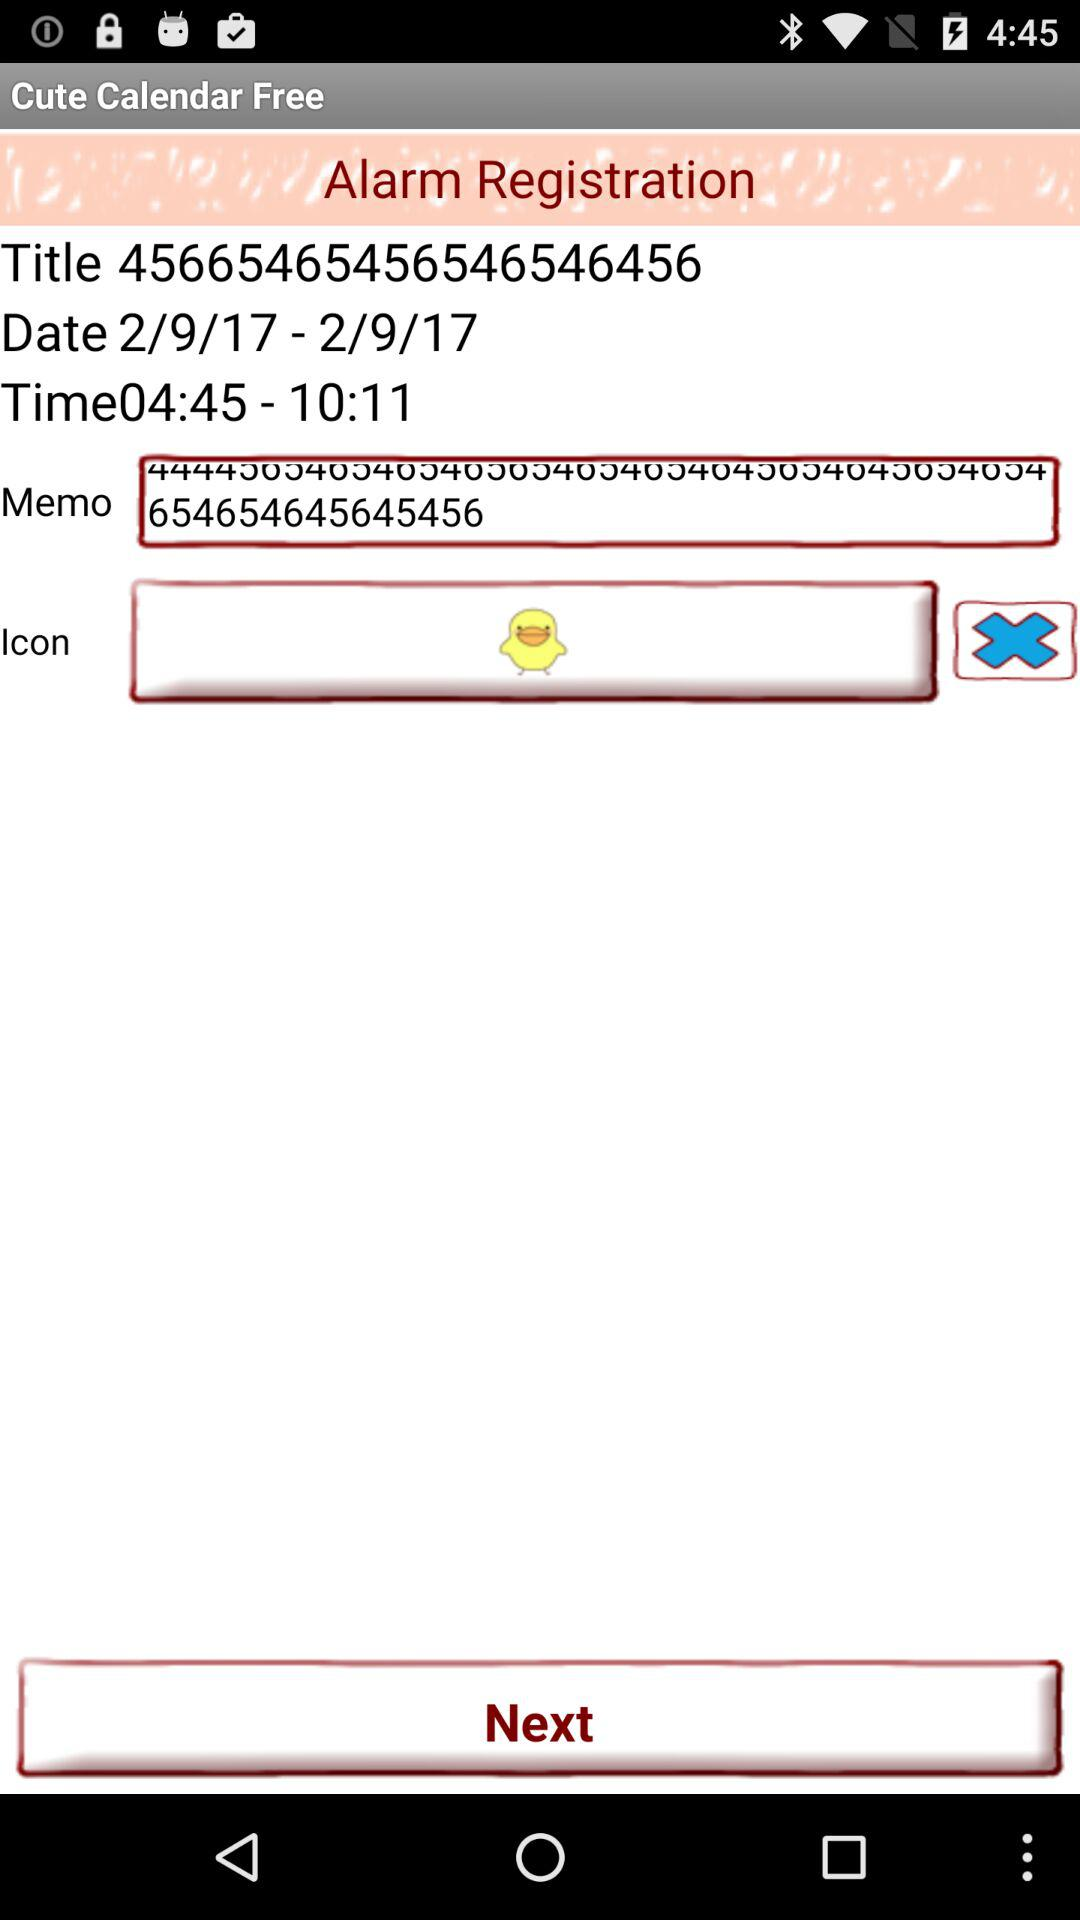What time range is mentioned? The mentioned time range is 4:45 to 10:11. 